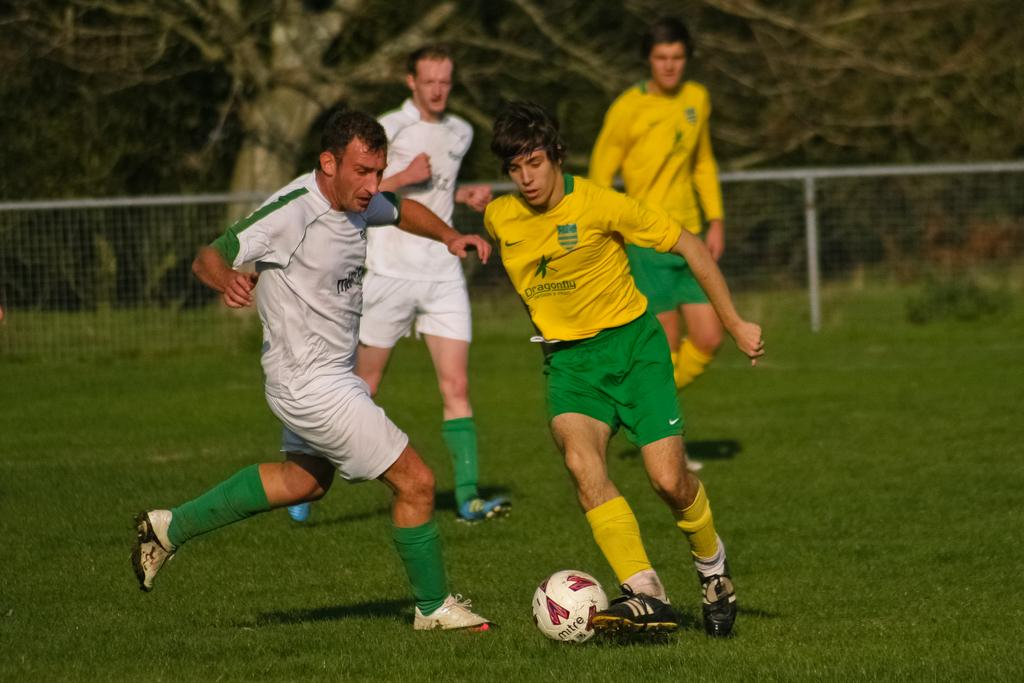How many people are playing football in the image? There are four people in the image. What are the people doing in the image? The people are playing football. What can be seen in the background of the image? There are trees in the background of the image. What is the ground covered with in the image? The ground is covered in greenery. What type of bucket is being used to burn the football in the image? There is no bucket or burning of the football in the image. The people are simply playing football on a grassy field with trees in the background. 